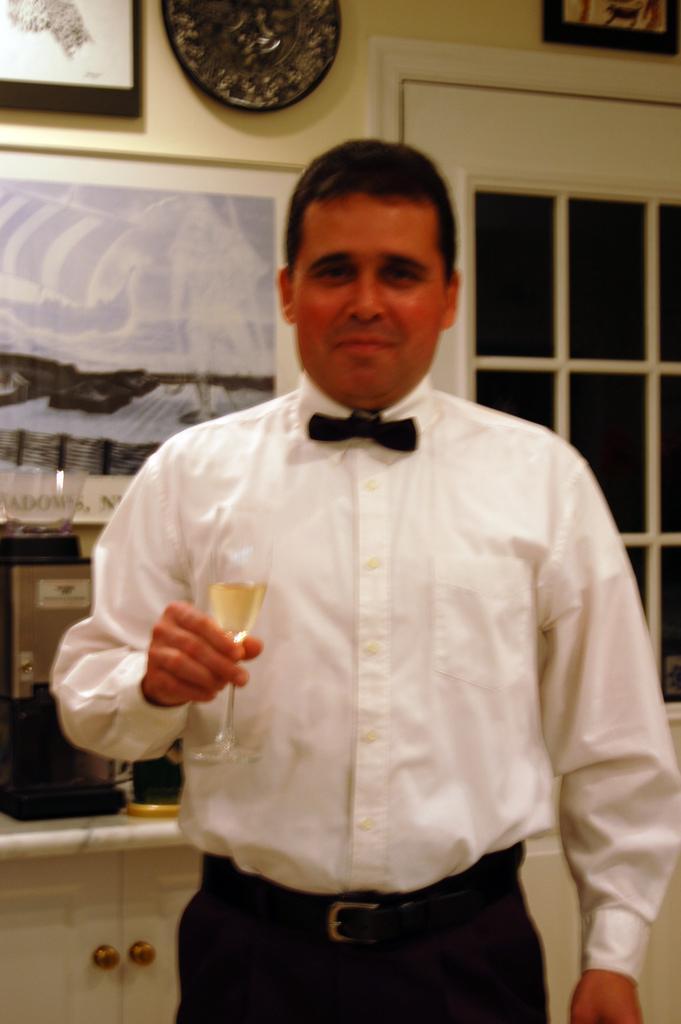How would you summarize this image in a sentence or two? In this image there is a man, holding a wine glass. And he is wearing white shirt and black pant. In the background there is a wall , photo frames and window. 